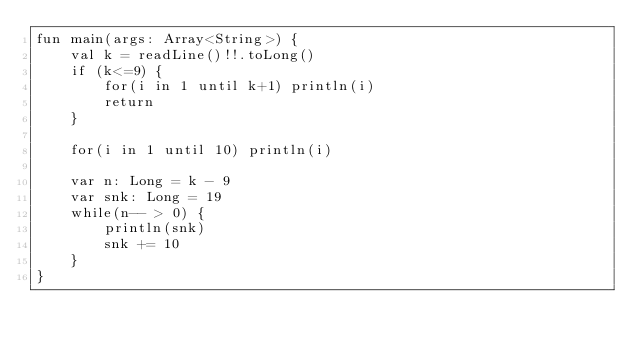<code> <loc_0><loc_0><loc_500><loc_500><_Kotlin_>fun main(args: Array<String>) {
    val k = readLine()!!.toLong()
    if (k<=9) {
        for(i in 1 until k+1) println(i)
        return
    }

    for(i in 1 until 10) println(i)

    var n: Long = k - 9
    var snk: Long = 19
    while(n-- > 0) {
        println(snk)
        snk += 10
    }
}</code> 